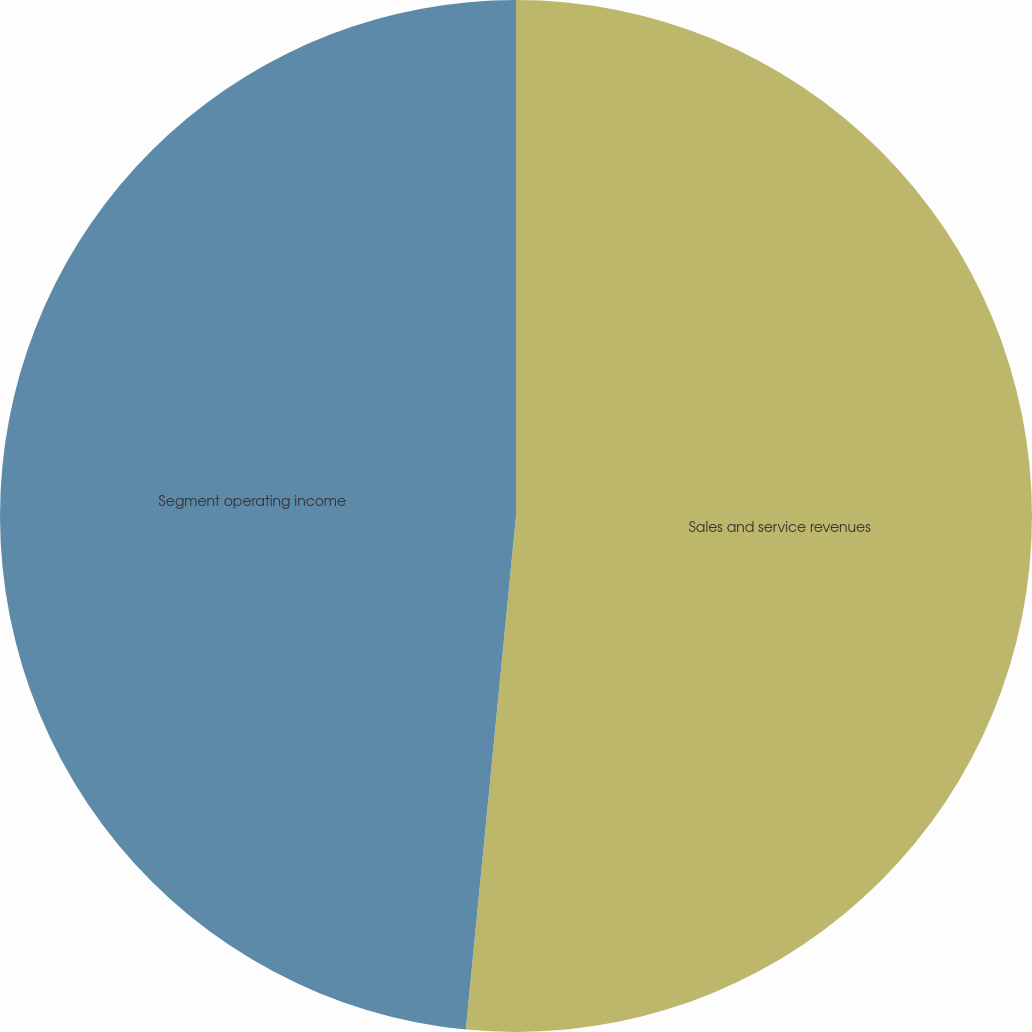<chart> <loc_0><loc_0><loc_500><loc_500><pie_chart><fcel>Sales and service revenues<fcel>Segment operating income<nl><fcel>51.55%<fcel>48.45%<nl></chart> 